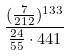<formula> <loc_0><loc_0><loc_500><loc_500>\frac { ( \frac { 7 } { 2 1 2 } ) ^ { 1 3 3 } } { \frac { 2 4 } { 5 5 } \cdot 4 4 1 }</formula> 